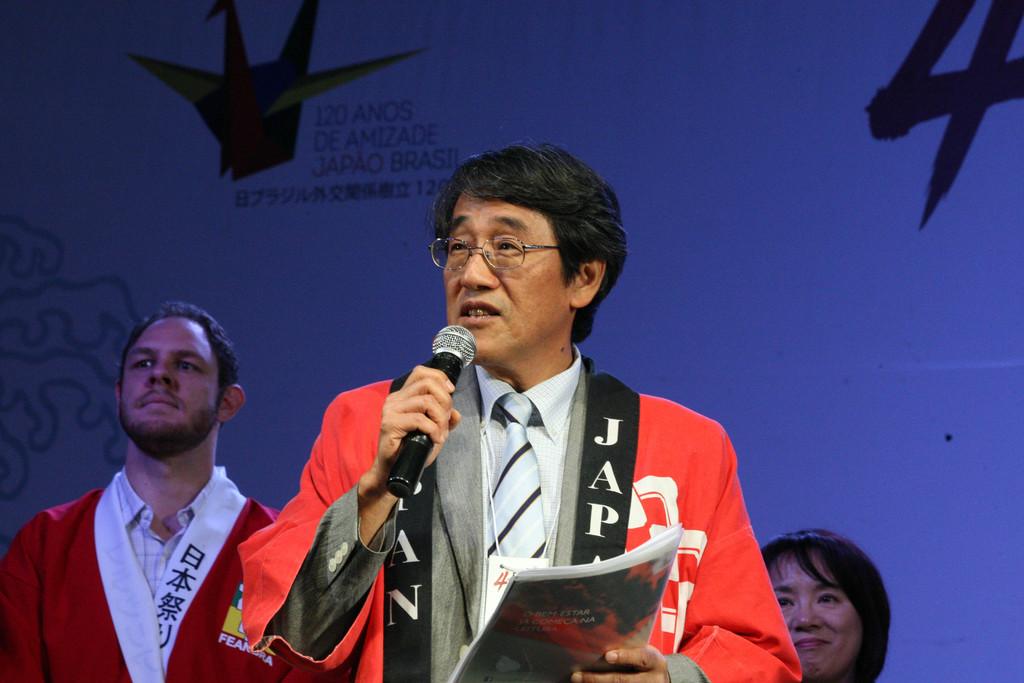What country name is displayed on this man's robe?
Your answer should be very brief. Japan. How many amos does the sign say?
Give a very brief answer. 120. 